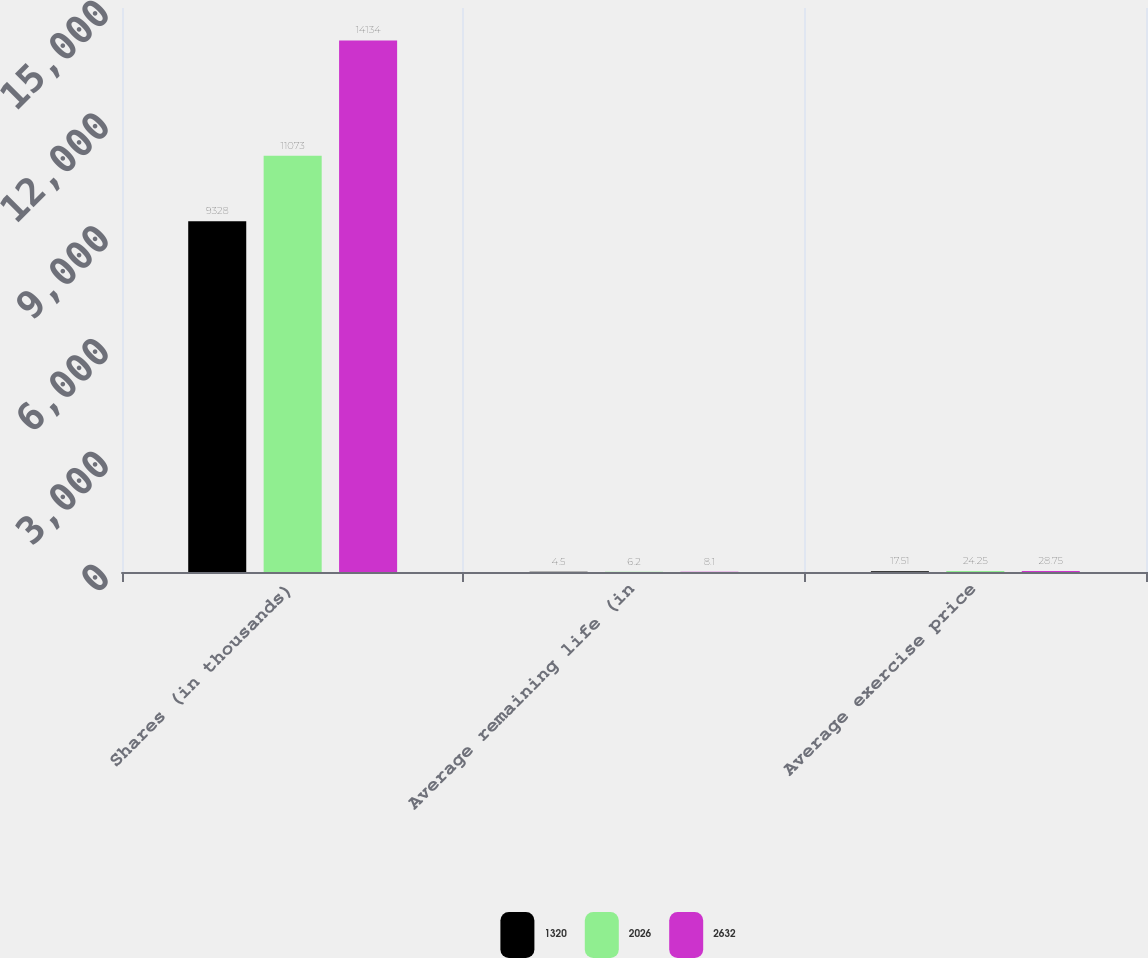Convert chart to OTSL. <chart><loc_0><loc_0><loc_500><loc_500><stacked_bar_chart><ecel><fcel>Shares (in thousands)<fcel>Average remaining life (in<fcel>Average exercise price<nl><fcel>1320<fcel>9328<fcel>4.5<fcel>17.51<nl><fcel>2026<fcel>11073<fcel>6.2<fcel>24.25<nl><fcel>2632<fcel>14134<fcel>8.1<fcel>28.75<nl></chart> 